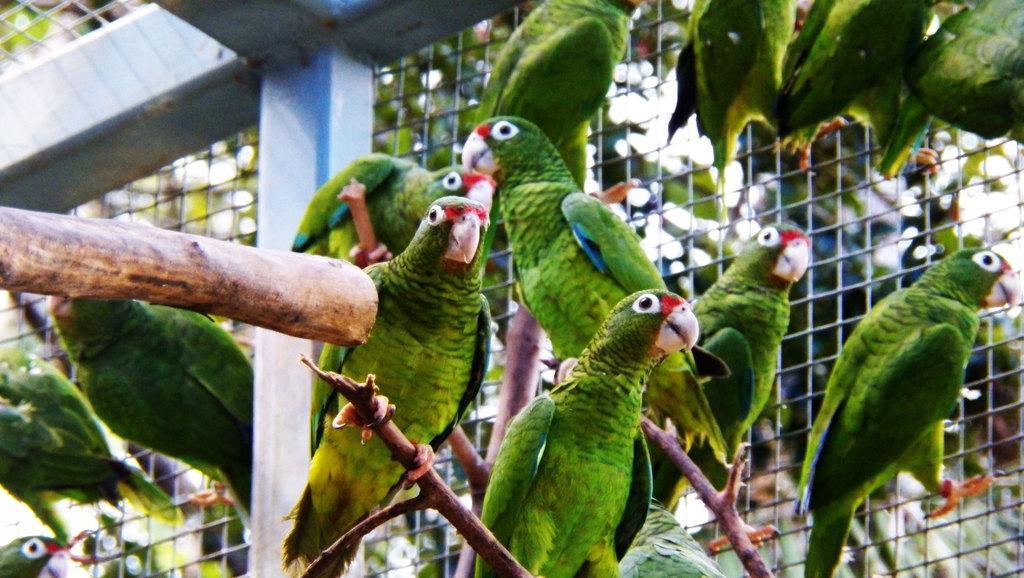Can you describe this image briefly? In this image we can see parrots and wooden sticks. In the background of the image there is grill. 